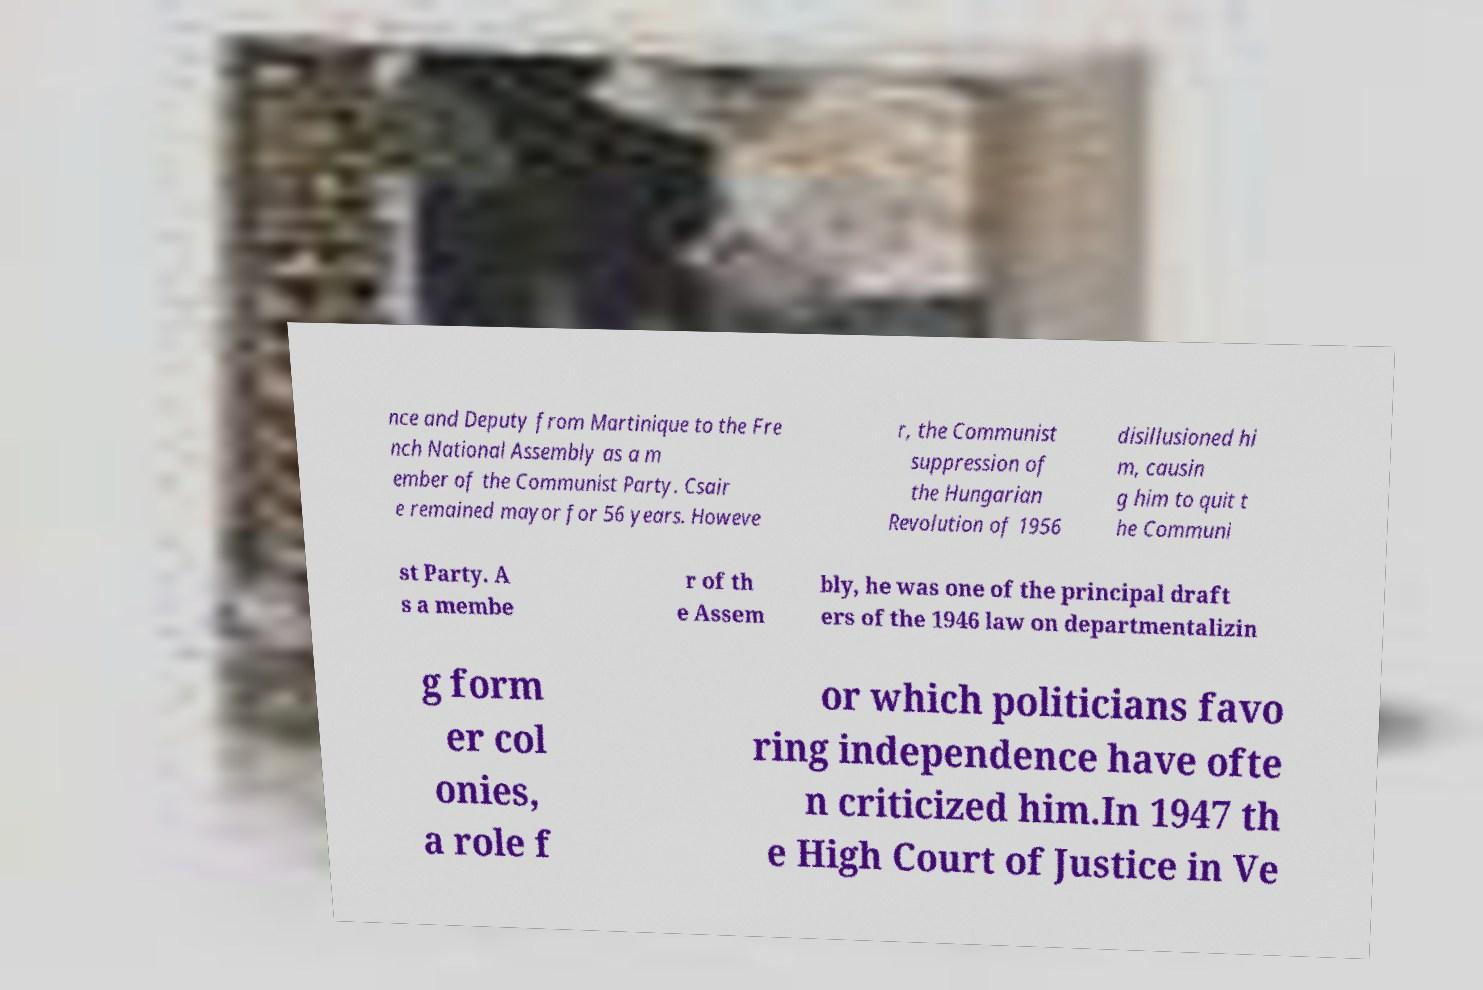Please read and relay the text visible in this image. What does it say? nce and Deputy from Martinique to the Fre nch National Assembly as a m ember of the Communist Party. Csair e remained mayor for 56 years. Howeve r, the Communist suppression of the Hungarian Revolution of 1956 disillusioned hi m, causin g him to quit t he Communi st Party. A s a membe r of th e Assem bly, he was one of the principal draft ers of the 1946 law on departmentalizin g form er col onies, a role f or which politicians favo ring independence have ofte n criticized him.In 1947 th e High Court of Justice in Ve 